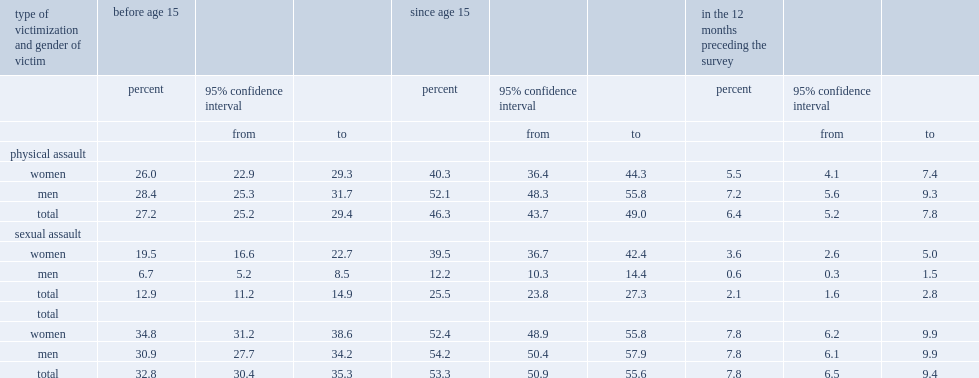What was the percentage of territory residents reported having been the victim of at least one assault, physical or sexual, since the age of 15? 53.3. Who were more likely to report having been victims of assault at some point in their lives since the age of 15,men or women? Men. What were the percentages of women and men who have been sexually assaulted at least once since the age of 15 respectively? 39.5 12.2. Who were more likely to have been victims of physical assault since the age of 15,women or men? Men. What was the percentage of territory residents reported having experienced at least one sexual or physical assault in the 12 months? 7.8. What were the percentages of men and women reported having experienced at least one sexual or physical assault in the 12 months respectively? 7.8 7.8. Which type of assault was more frequently reported by both women and men in the 12 months? Physical assault. Which type of assault was less frequently reported by men in the 12 months? Sexual assault. What was the percentage of women reported having been sexually assaulted in the 12 months? 3.6. 